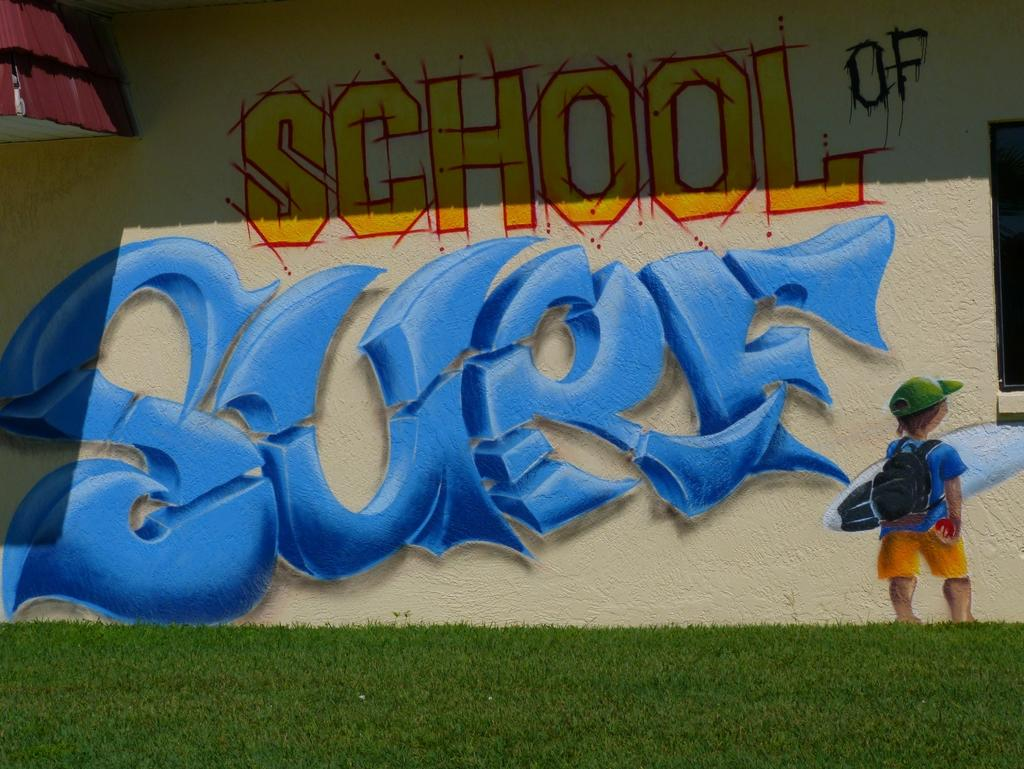What is depicted on the wall in the image? There is a painting on the wall in the image. What type of surface is on the ground in the image? There is grass on the ground in the image. Can you describe the object on the right side of the image? There is a black-colored object on the right side of the image. How does the grass sort itself in the image? The grass does not sort itself in the image; it is a natural surface that grows and spreads randomly. What is the texture of the painting in the image? The texture of the painting cannot be determined from the image alone, as it depends on the medium and technique used by the artist. 